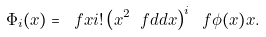Convert formula to latex. <formula><loc_0><loc_0><loc_500><loc_500>\Phi _ { i } ( x ) = \ f { x } { i ! } \left ( x ^ { 2 } \ f { d } { d x } \right ) ^ { i } \ f { \phi ( x ) } { x } .</formula> 